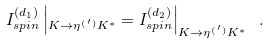Convert formula to latex. <formula><loc_0><loc_0><loc_500><loc_500>I _ { s p i n } ^ { ( d _ { 1 } ) } \left | _ { K \to \eta ^ { ( \, ^ { \prime } ) } K ^ { * } } = I _ { s p i n } ^ { ( d _ { 2 } ) } \right | _ { K \to \eta ^ { ( \, ^ { \prime } ) } K ^ { * } } \ .</formula> 